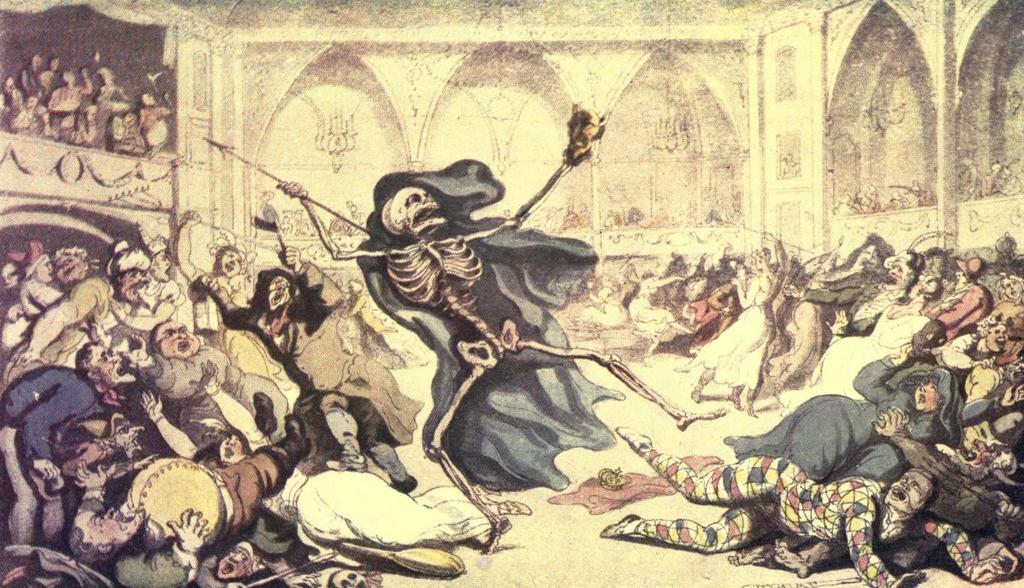What is depicted in the painting in the image? There is a painting of persons in the image. What object is covered with a cloth in the image? A skeleton is covered with a cloth in the image. How many other persons can be seen in the image besides those in the painting? There are other persons visible in the image. What can be seen in the background of the image? There is a wall in the background of the image. Where are some of the persons located in the image? There are persons on a balcony in the image. What type of quill is being used by the persons in the image? There is no quill present in the image. What type of approval is being sought by the persons in the image? There is no indication of approval being sought in the image. --- 